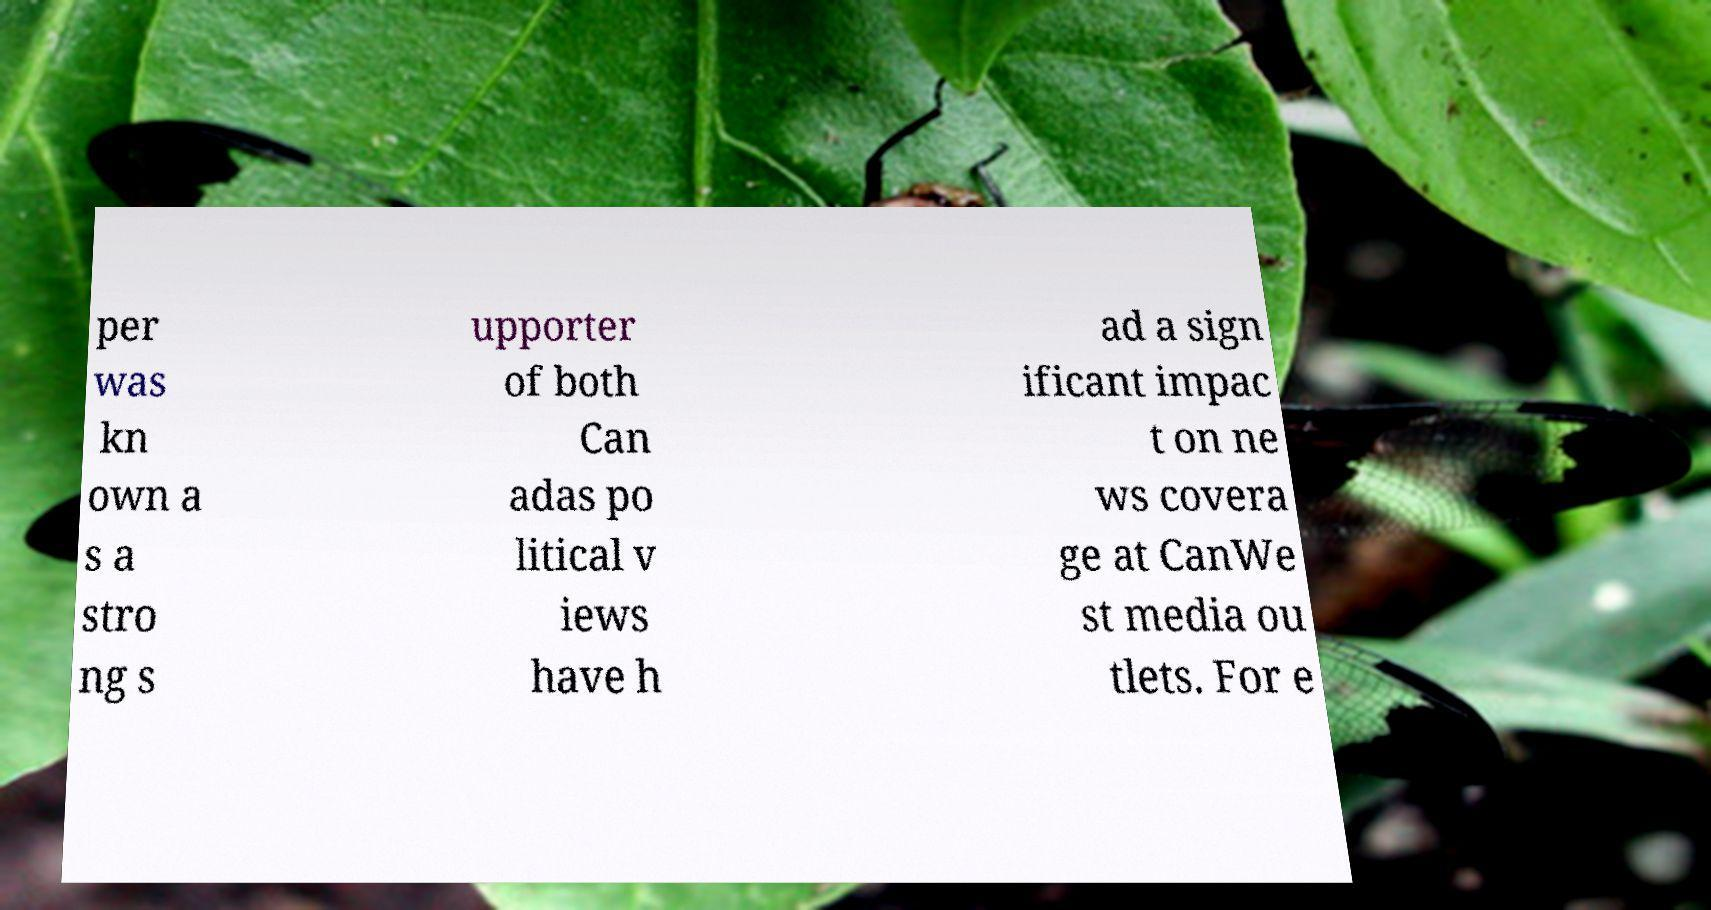What messages or text are displayed in this image? I need them in a readable, typed format. per was kn own a s a stro ng s upporter of both Can adas po litical v iews have h ad a sign ificant impac t on ne ws covera ge at CanWe st media ou tlets. For e 